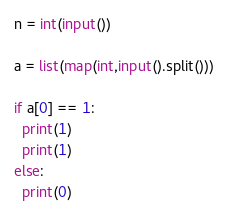Convert code to text. <code><loc_0><loc_0><loc_500><loc_500><_Python_>n = int(input())

a = list(map(int,input().split()))

if a[0] == 1:
  print(1)
  print(1)
else:
  print(0)</code> 